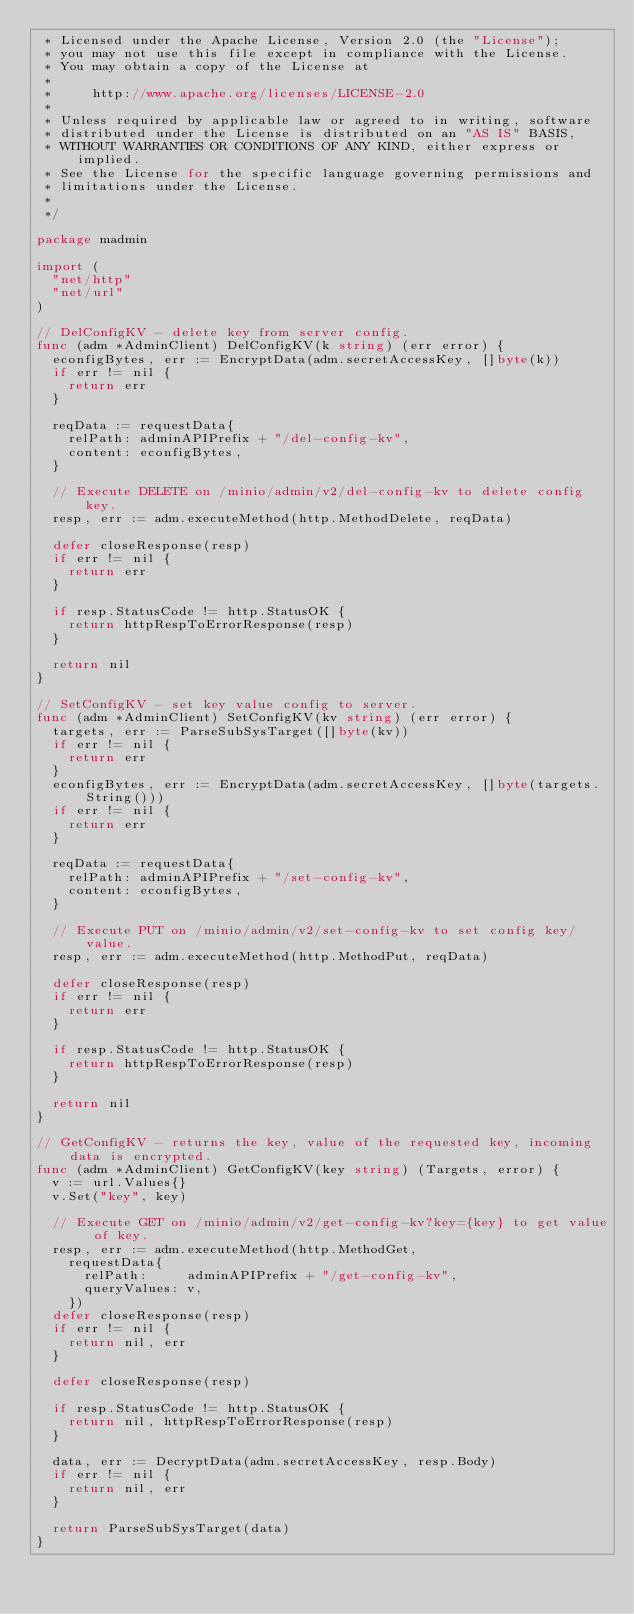<code> <loc_0><loc_0><loc_500><loc_500><_Go_> * Licensed under the Apache License, Version 2.0 (the "License");
 * you may not use this file except in compliance with the License.
 * You may obtain a copy of the License at
 *
 *     http://www.apache.org/licenses/LICENSE-2.0
 *
 * Unless required by applicable law or agreed to in writing, software
 * distributed under the License is distributed on an "AS IS" BASIS,
 * WITHOUT WARRANTIES OR CONDITIONS OF ANY KIND, either express or implied.
 * See the License for the specific language governing permissions and
 * limitations under the License.
 *
 */

package madmin

import (
	"net/http"
	"net/url"
)

// DelConfigKV - delete key from server config.
func (adm *AdminClient) DelConfigKV(k string) (err error) {
	econfigBytes, err := EncryptData(adm.secretAccessKey, []byte(k))
	if err != nil {
		return err
	}

	reqData := requestData{
		relPath: adminAPIPrefix + "/del-config-kv",
		content: econfigBytes,
	}

	// Execute DELETE on /minio/admin/v2/del-config-kv to delete config key.
	resp, err := adm.executeMethod(http.MethodDelete, reqData)

	defer closeResponse(resp)
	if err != nil {
		return err
	}

	if resp.StatusCode != http.StatusOK {
		return httpRespToErrorResponse(resp)
	}

	return nil
}

// SetConfigKV - set key value config to server.
func (adm *AdminClient) SetConfigKV(kv string) (err error) {
	targets, err := ParseSubSysTarget([]byte(kv))
	if err != nil {
		return err
	}
	econfigBytes, err := EncryptData(adm.secretAccessKey, []byte(targets.String()))
	if err != nil {
		return err
	}

	reqData := requestData{
		relPath: adminAPIPrefix + "/set-config-kv",
		content: econfigBytes,
	}

	// Execute PUT on /minio/admin/v2/set-config-kv to set config key/value.
	resp, err := adm.executeMethod(http.MethodPut, reqData)

	defer closeResponse(resp)
	if err != nil {
		return err
	}

	if resp.StatusCode != http.StatusOK {
		return httpRespToErrorResponse(resp)
	}

	return nil
}

// GetConfigKV - returns the key, value of the requested key, incoming data is encrypted.
func (adm *AdminClient) GetConfigKV(key string) (Targets, error) {
	v := url.Values{}
	v.Set("key", key)

	// Execute GET on /minio/admin/v2/get-config-kv?key={key} to get value of key.
	resp, err := adm.executeMethod(http.MethodGet,
		requestData{
			relPath:     adminAPIPrefix + "/get-config-kv",
			queryValues: v,
		})
	defer closeResponse(resp)
	if err != nil {
		return nil, err
	}

	defer closeResponse(resp)

	if resp.StatusCode != http.StatusOK {
		return nil, httpRespToErrorResponse(resp)
	}

	data, err := DecryptData(adm.secretAccessKey, resp.Body)
	if err != nil {
		return nil, err
	}

	return ParseSubSysTarget(data)
}
</code> 